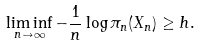<formula> <loc_0><loc_0><loc_500><loc_500>\liminf _ { n \to \infty } - \frac { 1 } { n } \log \pi _ { n } ( X _ { n } ) \geq h .</formula> 